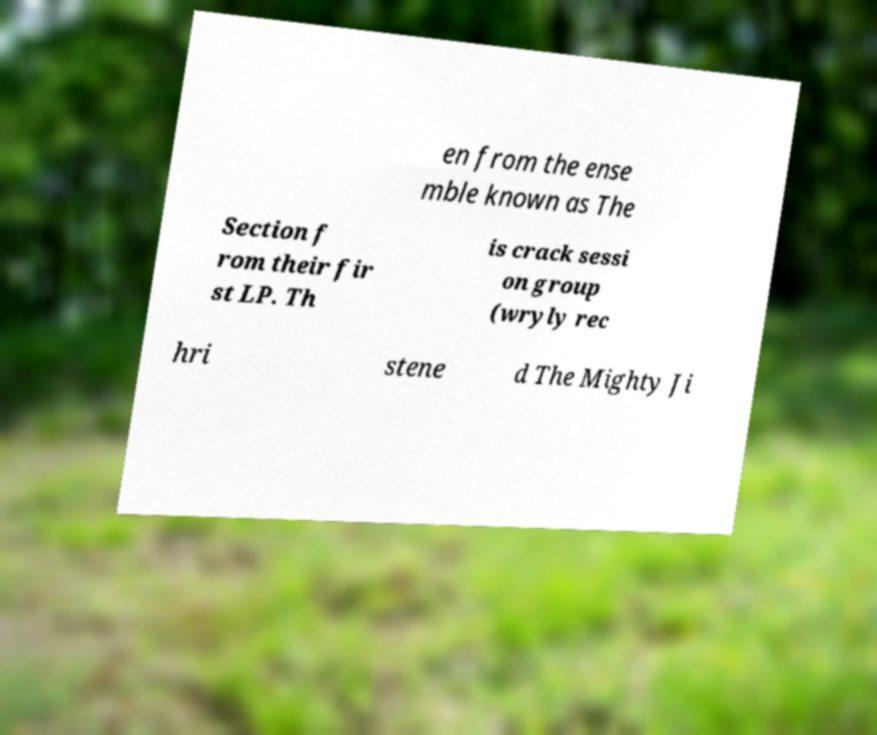There's text embedded in this image that I need extracted. Can you transcribe it verbatim? en from the ense mble known as The Section f rom their fir st LP. Th is crack sessi on group (wryly rec hri stene d The Mighty Ji 